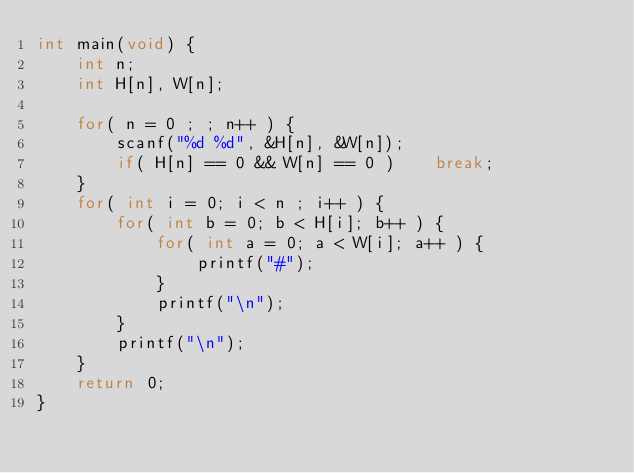<code> <loc_0><loc_0><loc_500><loc_500><_C_>int main(void) {
    int n;
    int H[n], W[n];
    
    for( n = 0 ; ; n++ ) {
        scanf("%d %d", &H[n], &W[n]);
        if( H[n] == 0 && W[n] == 0 )    break;
    }
    for( int i = 0; i < n ; i++ ) {
        for( int b = 0; b < H[i]; b++ ) {
            for( int a = 0; a < W[i]; a++ ) {
                printf("#");
            }
            printf("\n");
        }
        printf("\n");
    }
    return 0;
}
</code> 